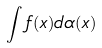Convert formula to latex. <formula><loc_0><loc_0><loc_500><loc_500>\int f ( x ) d \alpha ( x )</formula> 